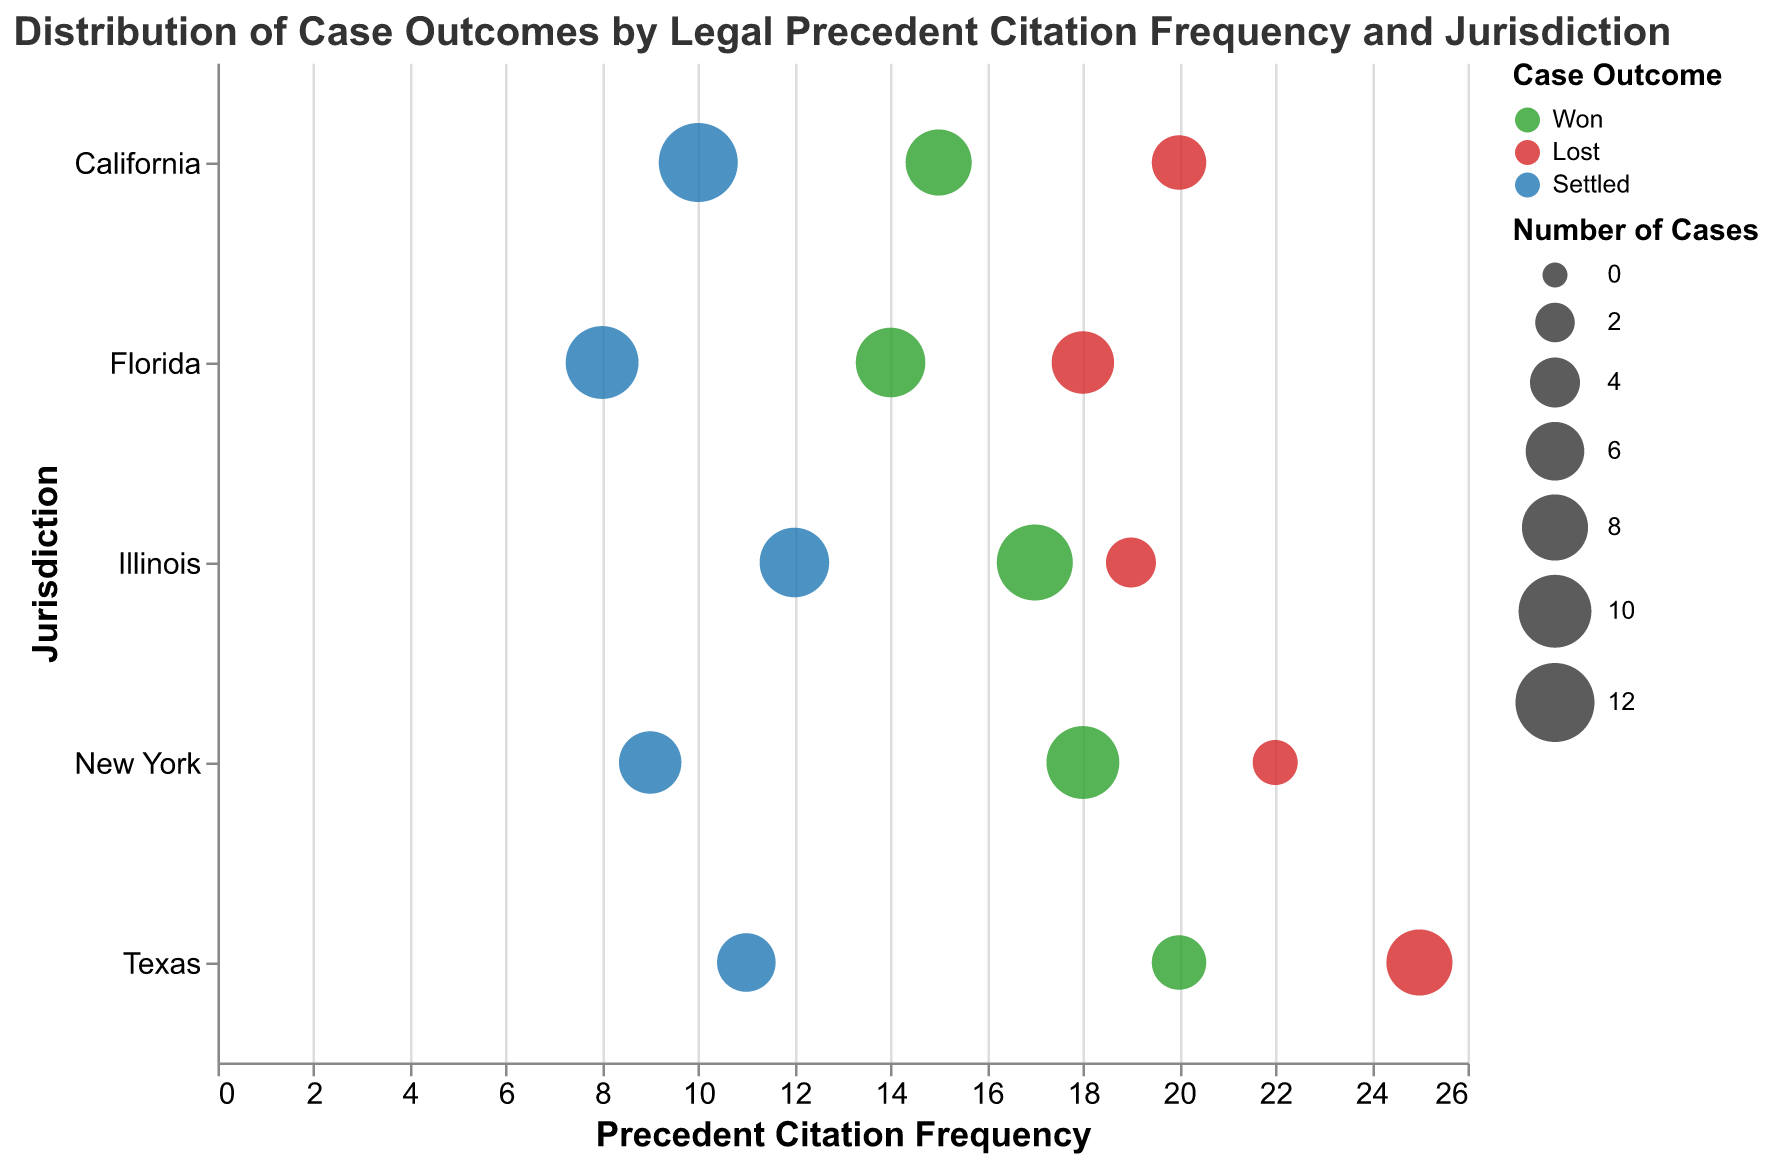What's the title of the chart? The title is located at the top of the chart, specifying what information will be visualized, which reads, "Distribution of Case Outcomes by Legal Precedent Citation Frequency and Jurisdiction".
Answer: Distribution of Case Outcomes by Legal Precedent Citation Frequency and Jurisdiction What's the horizontal axis representing? The horizontal axis (x-axis) shows the Precedent Citation Frequency, which indicates how often legal precedents are cited in the cases.
Answer: Precedent Citation Frequency Which jurisdiction has the highest Precedent Citation Frequency for lost cases? By looking at the "Lost" cases indicated by the red color, we see that Texas has a Precedent Citation Frequency of 25 for lost cases, the highest on the x-axis for this category.
Answer: Texas How many cases were 'Won' in New York, and what is their Citation Frequency? Look for green-colored bubbles within the New York row. The tooltip or size of the bubble shows that New York has 10 "Won" cases with a Precedent Citation Frequency of 18.
Answer: 10 cases, Frequency 18 In which jurisdiction were the most cases settled, and what is the Citation Frequency? Blue-colored bubbles indicate settled cases. California has the largest bubble for settled cases, with 12, and a Citation Frequency of 10.
Answer: California, Frequency 10 Calculate the total number of "Won" cases across all jurisdictions. Sum up all the "Won" cases represented by green bubbles: California (8) + New York (10) + Texas (5) + Florida (9) + Illinois (11) = 43.
Answer: 43 Compare the number of cases that were "Lost" in Texas with those in Florida. Which has more? Texas has a red bubble representing 8 lost cases, while Florida's red bubble represents 7 lost cases. Therefore, Texas has more lost cases.
Answer: Texas Which jurisdiction shows the largest variation in Precedent Citation Frequency for different case outcomes? By observing the spread along the x-axis for each jurisdiction, Texas shows the largest variation with frequencies of 20 (Won), 25 (Lost), and 11 (Settled).
Answer: Texas Compare the number of "Settled" cases in Illinois with those in California. Which has more? Blue-colored bubbles indicate settled cases. California has 12 settled cases, whereas Illinois has 9. Thus, California has more settled cases.
Answer: California What is the range of Precedent Citation Frequency for cases in Florida? For Florida, look at all bubbles along the x-axis. The frequency ranges from the lowest at 8 (Settled) to the highest at 18 (Lost). Therefore, the range is from 8 to 18.
Answer: 8 to 18 